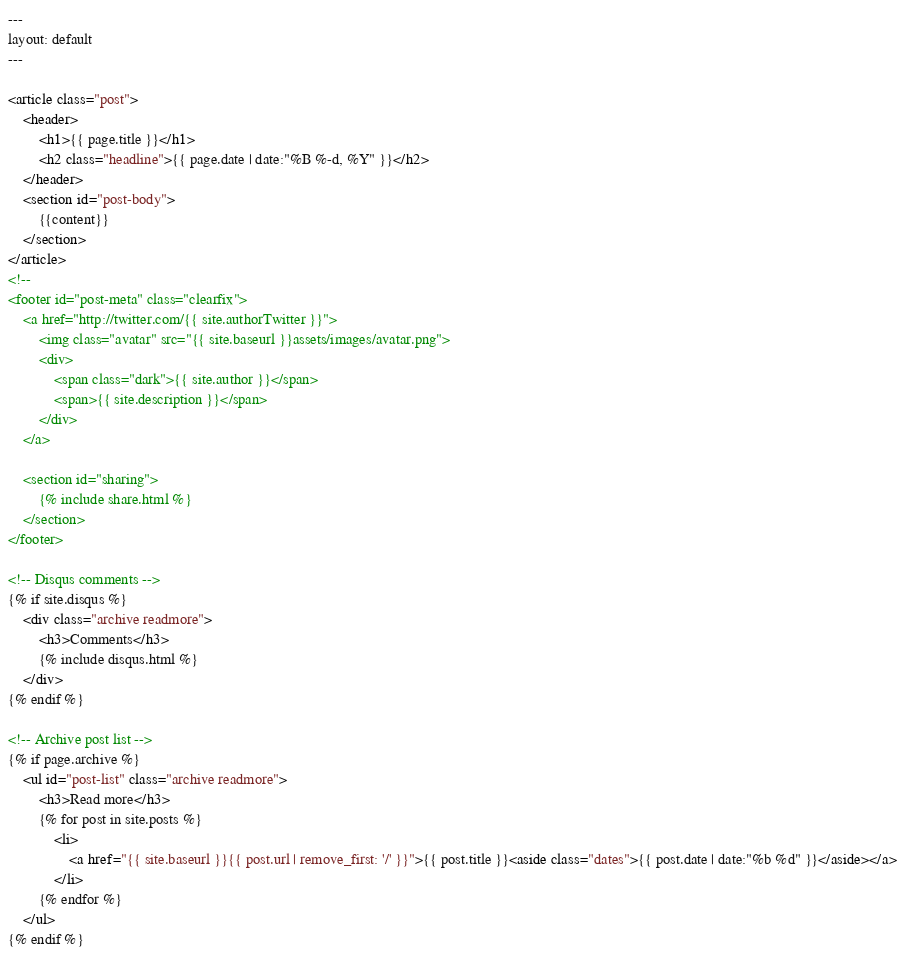<code> <loc_0><loc_0><loc_500><loc_500><_HTML_>---
layout: default
---

<article class="post">
    <header>
        <h1>{{ page.title }}</h1>
        <h2 class="headline">{{ page.date | date:"%B %-d, %Y" }}</h2>
    </header>
    <section id="post-body">
        {{content}}
    </section>
</article>
<!--
<footer id="post-meta" class="clearfix">
    <a href="http://twitter.com/{{ site.authorTwitter }}">
        <img class="avatar" src="{{ site.baseurl }}assets/images/avatar.png">
        <div>
            <span class="dark">{{ site.author }}</span>
            <span>{{ site.description }}</span>
        </div>
    </a>

    <section id="sharing">
        {% include share.html %}
    </section>
</footer>

<!-- Disqus comments -->
{% if site.disqus %}
    <div class="archive readmore">
        <h3>Comments</h3>
        {% include disqus.html %}
    </div>
{% endif %}

<!-- Archive post list -->
{% if page.archive %}
    <ul id="post-list" class="archive readmore">
        <h3>Read more</h3>
        {% for post in site.posts %}
            <li>
                <a href="{{ site.baseurl }}{{ post.url | remove_first: '/' }}">{{ post.title }}<aside class="dates">{{ post.date | date:"%b %d" }}</aside></a>
            </li>
        {% endfor %}
    </ul>
{% endif %}

</code> 